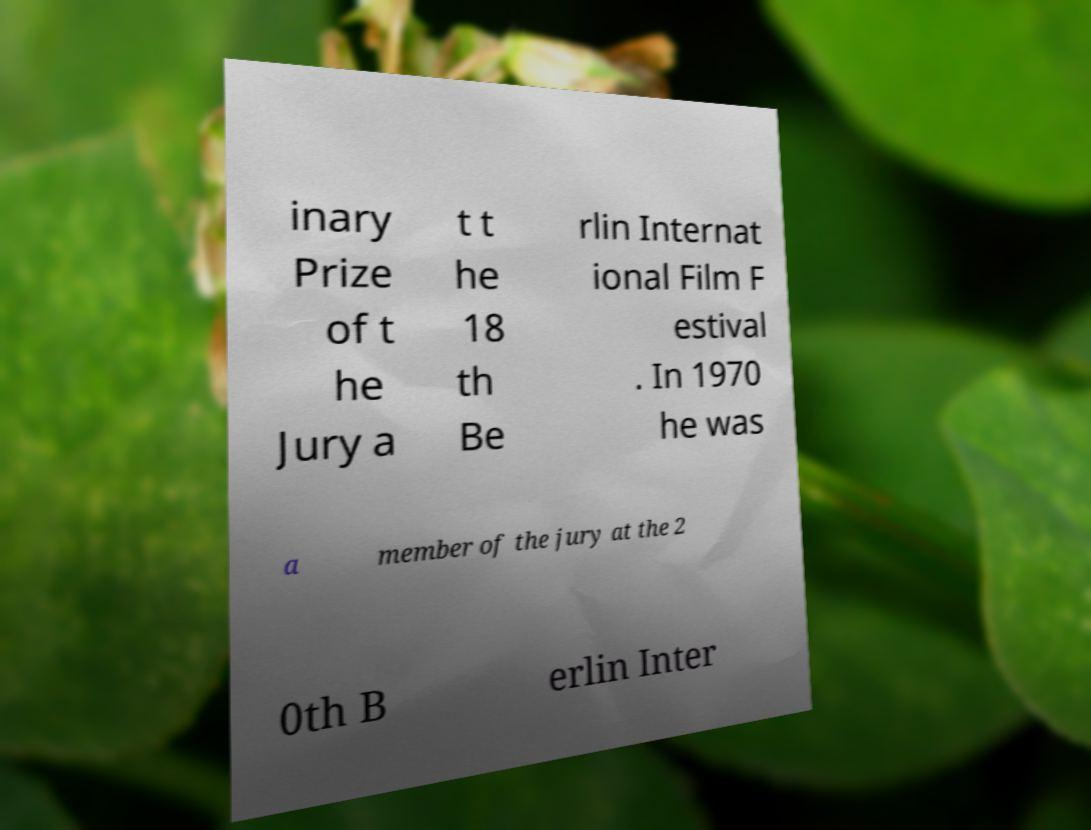Can you read and provide the text displayed in the image?This photo seems to have some interesting text. Can you extract and type it out for me? inary Prize of t he Jury a t t he 18 th Be rlin Internat ional Film F estival . In 1970 he was a member of the jury at the 2 0th B erlin Inter 